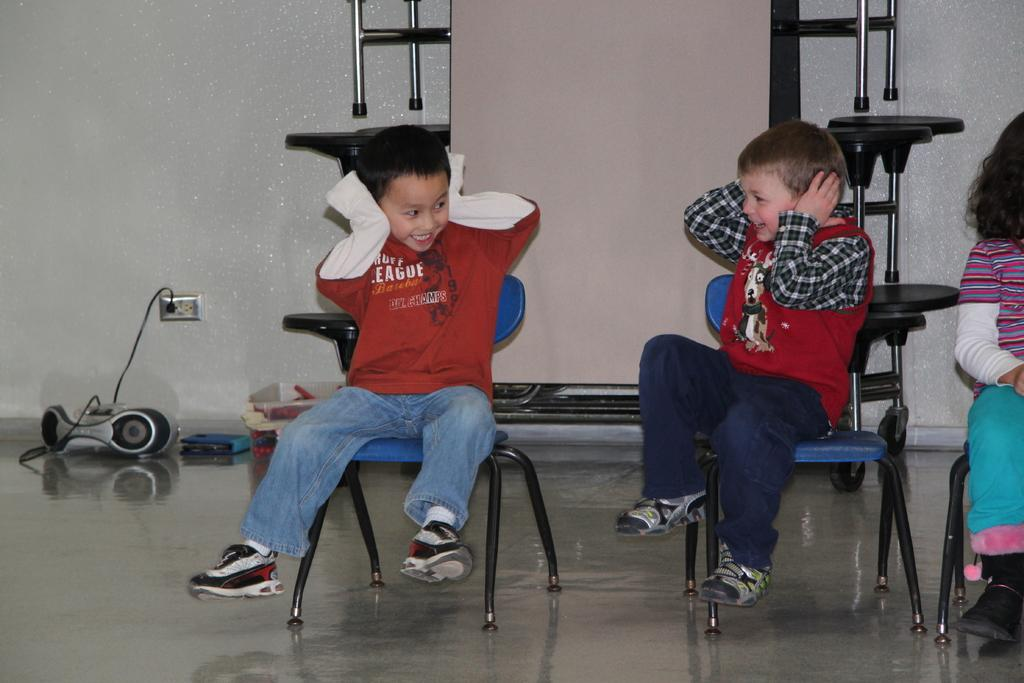How many children are present in the image? There are two children in the image. What are the children doing in the image? The children are sitting on chairs and smiling. What can be seen beneath the children's feet in the image? There is a floor visible in the image. What is visible behind the children in the image? There is a wall in the background of the image. What type of profit can be seen in the image? There is no profit visible in the image; it features two children sitting on chairs and smiling. 